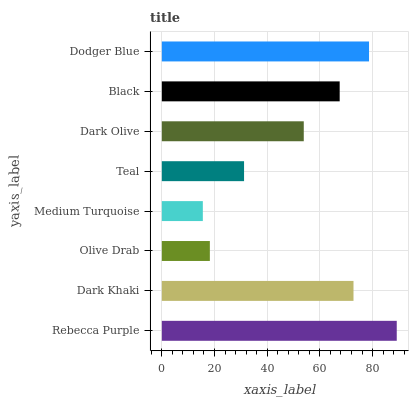Is Medium Turquoise the minimum?
Answer yes or no. Yes. Is Rebecca Purple the maximum?
Answer yes or no. Yes. Is Dark Khaki the minimum?
Answer yes or no. No. Is Dark Khaki the maximum?
Answer yes or no. No. Is Rebecca Purple greater than Dark Khaki?
Answer yes or no. Yes. Is Dark Khaki less than Rebecca Purple?
Answer yes or no. Yes. Is Dark Khaki greater than Rebecca Purple?
Answer yes or no. No. Is Rebecca Purple less than Dark Khaki?
Answer yes or no. No. Is Black the high median?
Answer yes or no. Yes. Is Dark Olive the low median?
Answer yes or no. Yes. Is Rebecca Purple the high median?
Answer yes or no. No. Is Olive Drab the low median?
Answer yes or no. No. 